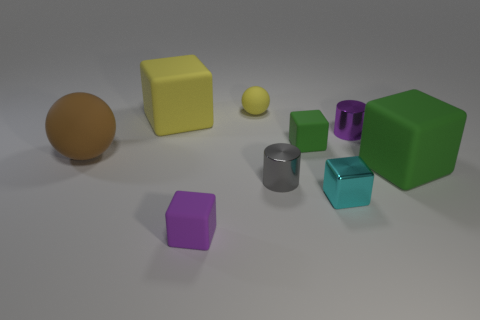Subtract all yellow matte blocks. How many blocks are left? 4 Subtract 2 cubes. How many cubes are left? 3 Subtract all green blocks. How many blocks are left? 3 Subtract all blue blocks. Subtract all purple spheres. How many blocks are left? 5 Subtract all cylinders. How many objects are left? 7 Subtract 0 red cylinders. How many objects are left? 9 Subtract all tiny red matte balls. Subtract all large yellow cubes. How many objects are left? 8 Add 8 large matte spheres. How many large matte spheres are left? 9 Add 5 tiny green things. How many tiny green things exist? 6 